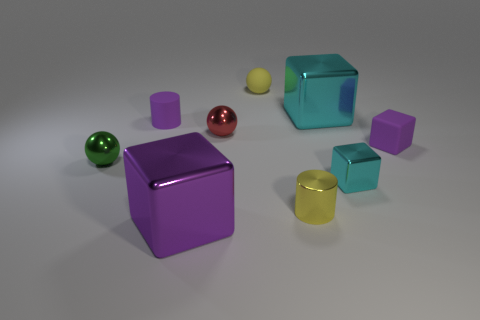Subtract all small green spheres. How many spheres are left? 2 Subtract all yellow balls. How many balls are left? 2 Subtract all yellow cylinders. How many purple blocks are left? 2 Add 8 tiny metal balls. How many tiny metal balls are left? 10 Add 6 tiny rubber balls. How many tiny rubber balls exist? 7 Subtract 1 red spheres. How many objects are left? 8 Subtract all blocks. How many objects are left? 5 Subtract 3 cubes. How many cubes are left? 1 Subtract all cyan cubes. Subtract all green cylinders. How many cubes are left? 2 Subtract all yellow objects. Subtract all purple cylinders. How many objects are left? 6 